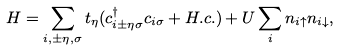<formula> <loc_0><loc_0><loc_500><loc_500>H = \sum _ { i , \pm \eta , \sigma } t _ { \eta } ( c _ { i \pm \eta \sigma } ^ { \dag } c _ { i \sigma } + H . c . ) + U \sum _ { i } n _ { i \uparrow } n _ { i \downarrow } ,</formula> 